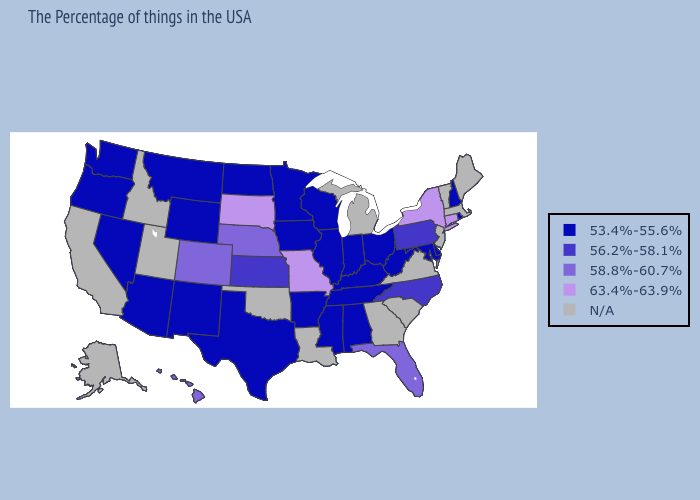What is the value of Mississippi?
Write a very short answer. 53.4%-55.6%. Among the states that border Colorado , does Nebraska have the highest value?
Keep it brief. Yes. Name the states that have a value in the range 63.4%-63.9%?
Write a very short answer. Connecticut, New York, Missouri, South Dakota. Does Rhode Island have the highest value in the USA?
Keep it brief. No. What is the value of Maine?
Give a very brief answer. N/A. Name the states that have a value in the range 53.4%-55.6%?
Give a very brief answer. Rhode Island, New Hampshire, Delaware, Maryland, West Virginia, Ohio, Kentucky, Indiana, Alabama, Tennessee, Wisconsin, Illinois, Mississippi, Arkansas, Minnesota, Iowa, Texas, North Dakota, Wyoming, New Mexico, Montana, Arizona, Nevada, Washington, Oregon. Which states have the highest value in the USA?
Concise answer only. Connecticut, New York, Missouri, South Dakota. What is the value of Missouri?
Quick response, please. 63.4%-63.9%. What is the value of Delaware?
Write a very short answer. 53.4%-55.6%. What is the value of California?
Be succinct. N/A. Is the legend a continuous bar?
Keep it brief. No. How many symbols are there in the legend?
Write a very short answer. 5. Name the states that have a value in the range 58.8%-60.7%?
Answer briefly. Florida, Nebraska, Colorado, Hawaii. 